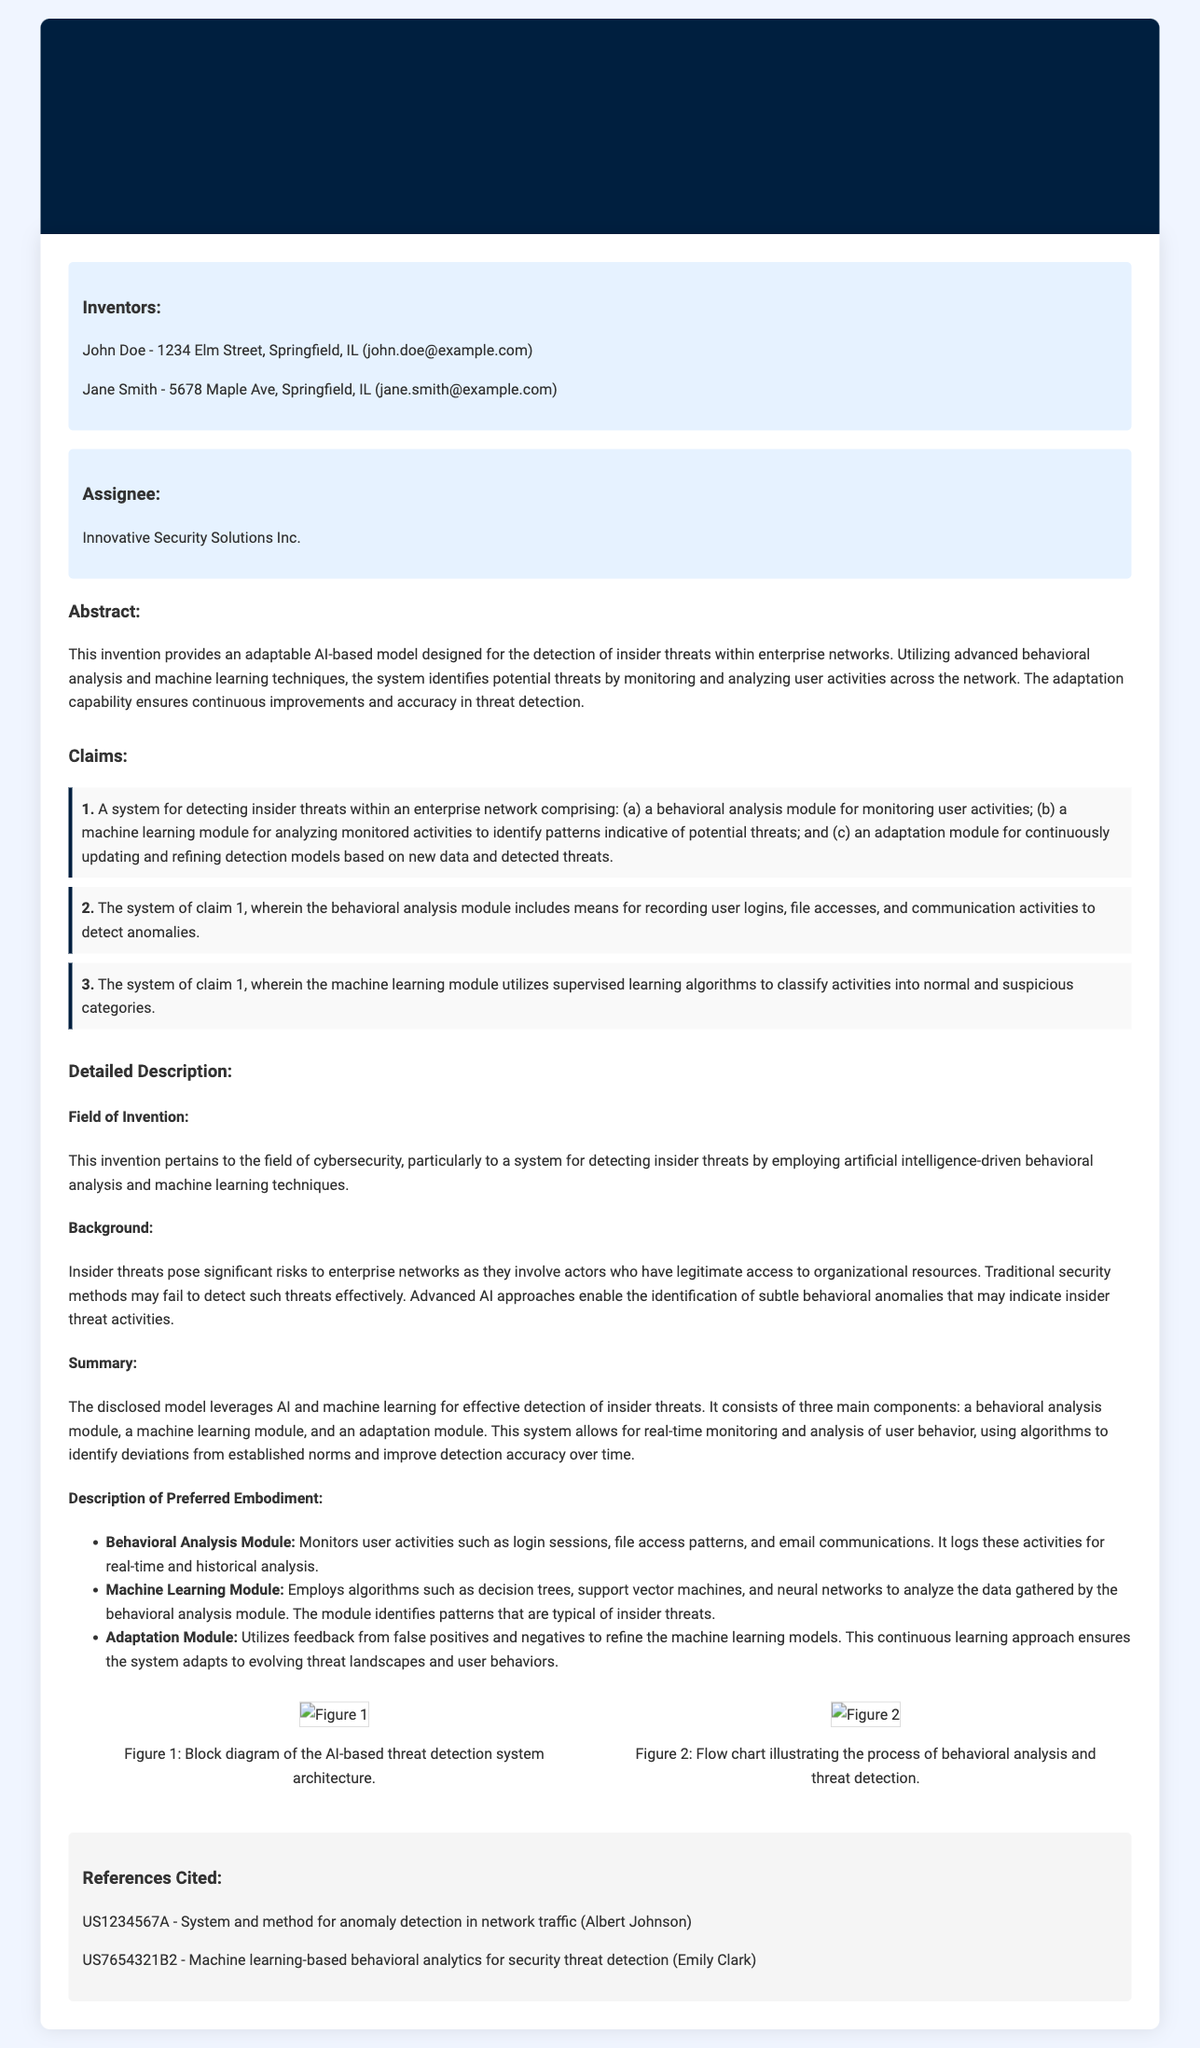What is the title of the patent application? The title of the patent application is provided in the header section of the document.
Answer: Adaptable AI-Based Model for Detection of Insider Threats through Behavioral Analysis and Machine Learning on Enterprise Networks Who are the inventors of the system? The names of the inventors are listed in the section labeled "Inventors."
Answer: John Doe, Jane Smith What is the primary purpose of the invention? The primary purpose is detailed in the abstract, which summarizes the invention's function.
Answer: Detection of insider threats How many claims are presented in the document? The number of claims can be counted within the "Claims" section.
Answer: 3 What component focuses on monitoring user activities? This information can be found in the detailed description where the components of the system are explained.
Answer: Behavioral analysis module What machine learning techniques are mentioned in the document? The techniques are listed in the detailed description under the machine learning module section.
Answer: Decision trees, support vector machines, neural networks What does the adaptation module utilize for improving accuracy? The adaptation module's description indicates what it uses for refinement.
Answer: Feedback from false positives and negatives What is the background of the invention related to? The background section provides context for the invention's development and its relevance to cybersecurity.
Answer: Insider threats Who is the assignee of the patent? The assignee information is stated in the section titled "Assignee."
Answer: Innovative Security Solutions Inc 